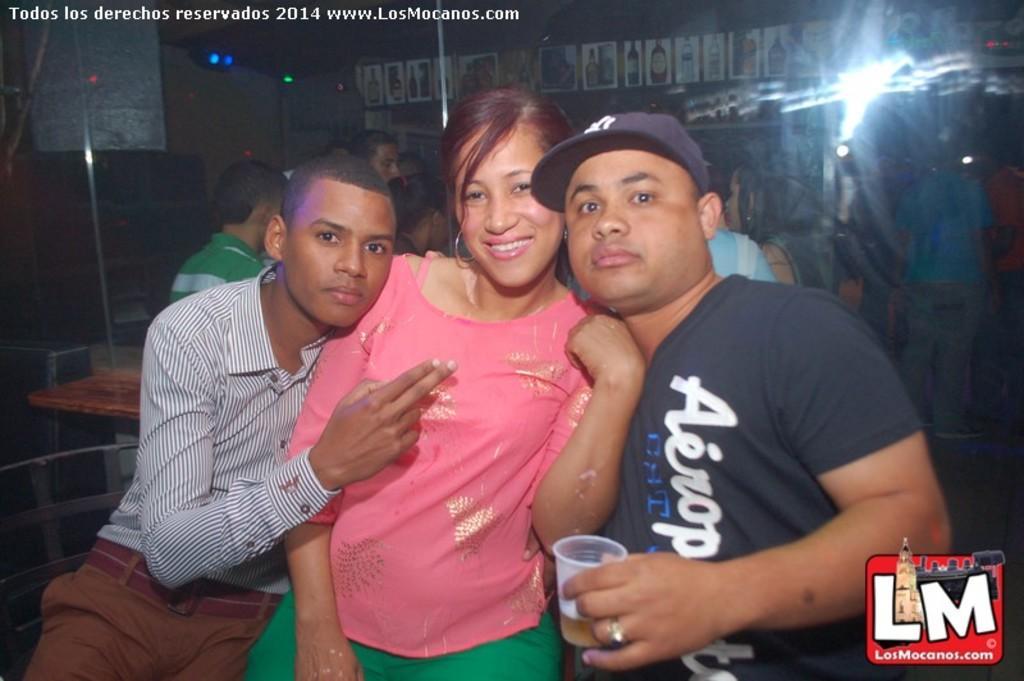How would you summarize this image in a sentence or two? In this picture there is a woman who is wearing pink top and green trouser. On the right there is a man who is wearing black cap, t-shirt and holding wine glass. On the left there is another man who is wearing shirt and trouser, sitting on the bench. In the background we can see group of persons standing near to the table. On the top we can see banner and light. On the top left corner there is a watermark. 